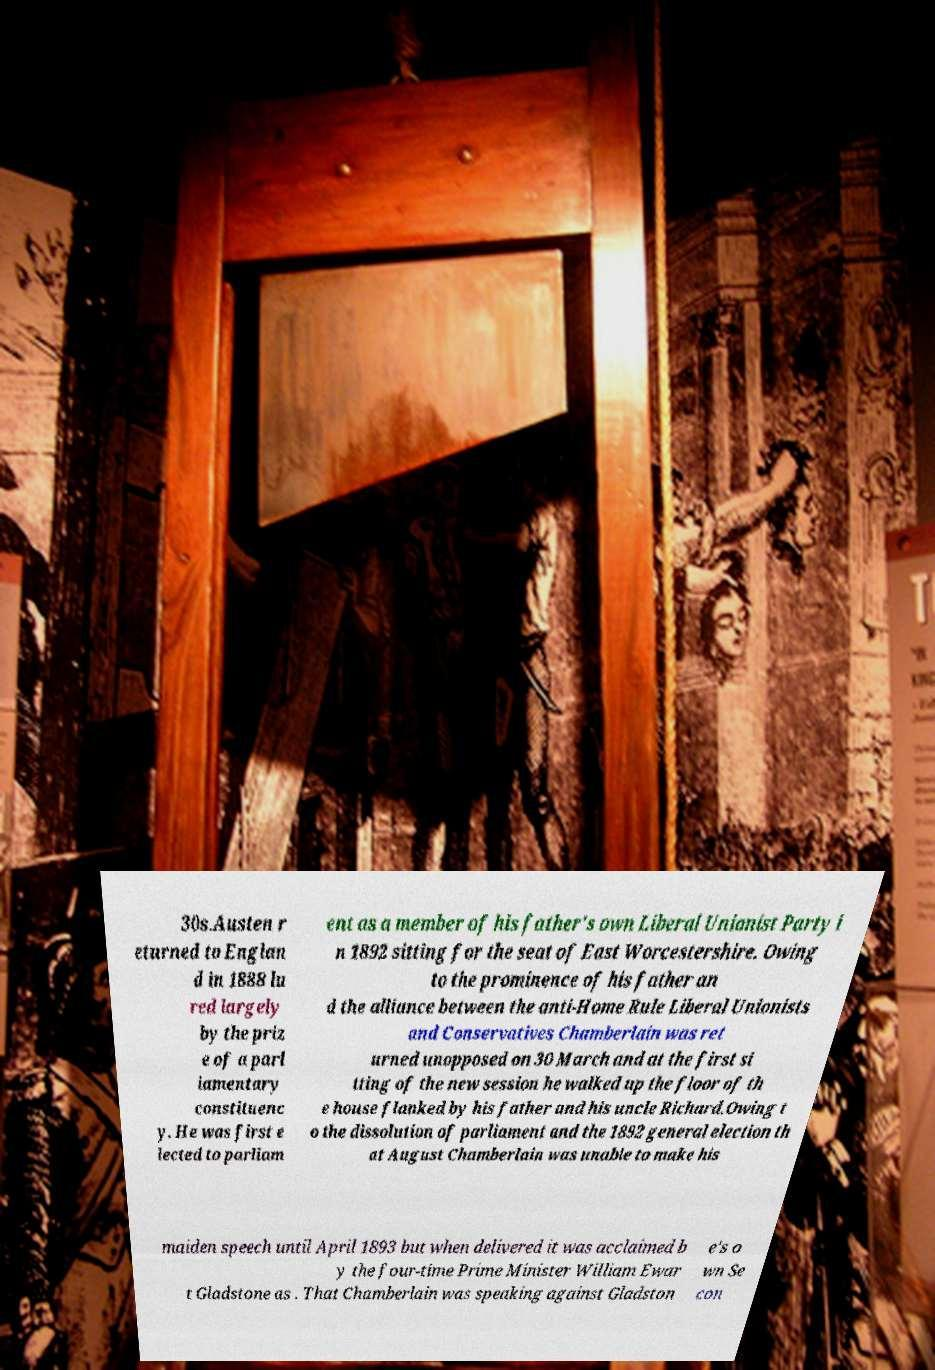Please read and relay the text visible in this image. What does it say? 30s.Austen r eturned to Englan d in 1888 lu red largely by the priz e of a parl iamentary constituenc y. He was first e lected to parliam ent as a member of his father's own Liberal Unionist Party i n 1892 sitting for the seat of East Worcestershire. Owing to the prominence of his father an d the alliance between the anti-Home Rule Liberal Unionists and Conservatives Chamberlain was ret urned unopposed on 30 March and at the first si tting of the new session he walked up the floor of th e house flanked by his father and his uncle Richard.Owing t o the dissolution of parliament and the 1892 general election th at August Chamberlain was unable to make his maiden speech until April 1893 but when delivered it was acclaimed b y the four-time Prime Minister William Ewar t Gladstone as . That Chamberlain was speaking against Gladston e's o wn Se con 